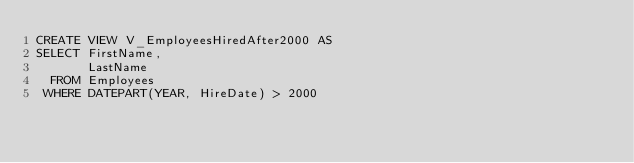<code> <loc_0><loc_0><loc_500><loc_500><_SQL_>CREATE VIEW V_EmployeesHiredAfter2000 AS
SELECT FirstName,
       LastName
  FROM Employees
 WHERE DATEPART(YEAR, HireDate) > 2000</code> 